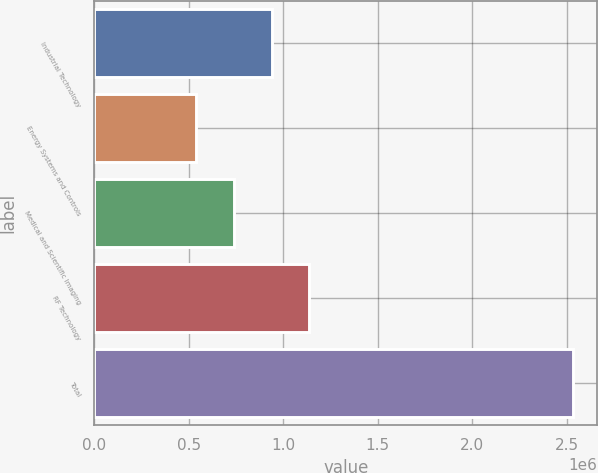Convert chart to OTSL. <chart><loc_0><loc_0><loc_500><loc_500><bar_chart><fcel>Industrial Technology<fcel>Energy Systems and Controls<fcel>Medical and Scientific Imaging<fcel>RF Technology<fcel>Total<nl><fcel>938336<fcel>538861<fcel>738598<fcel>1.13807e+06<fcel>2.53624e+06<nl></chart> 